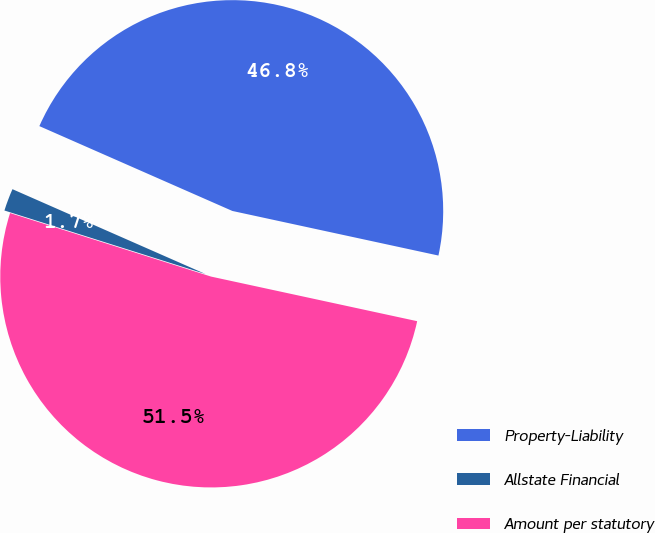Convert chart. <chart><loc_0><loc_0><loc_500><loc_500><pie_chart><fcel>Property-Liability<fcel>Allstate Financial<fcel>Amount per statutory<nl><fcel>46.8%<fcel>1.72%<fcel>51.48%<nl></chart> 